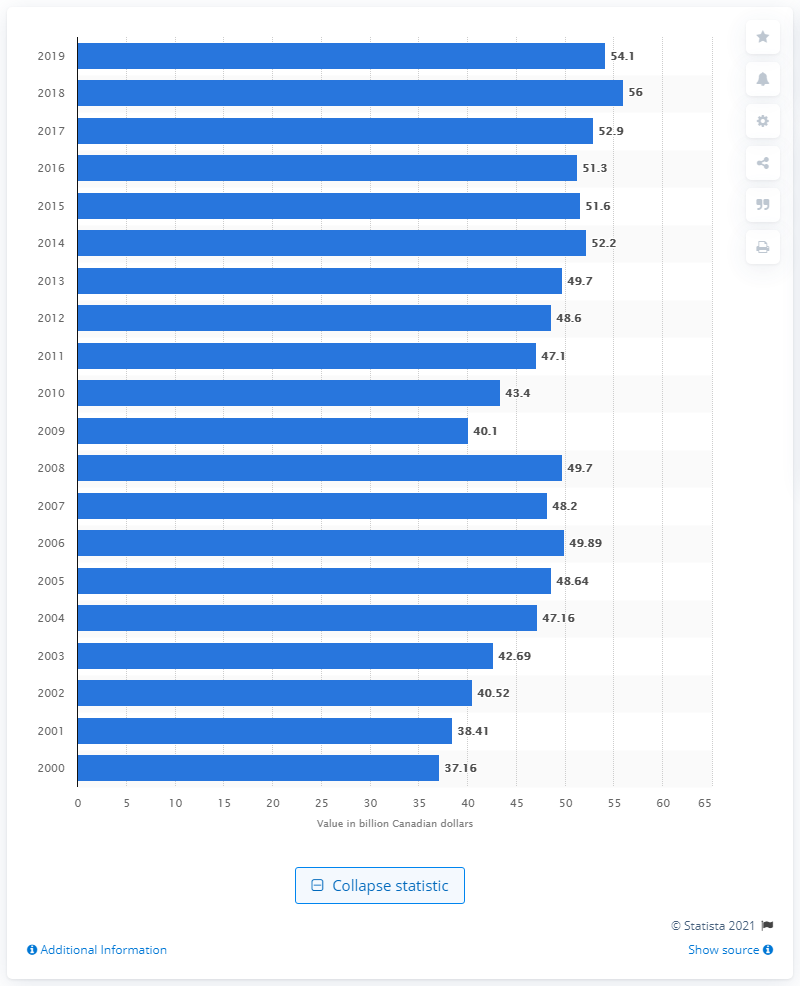Indicate a few pertinent items in this graphic. In 2019, the total value of Canadian chemical shipments was $54.1 billion. 